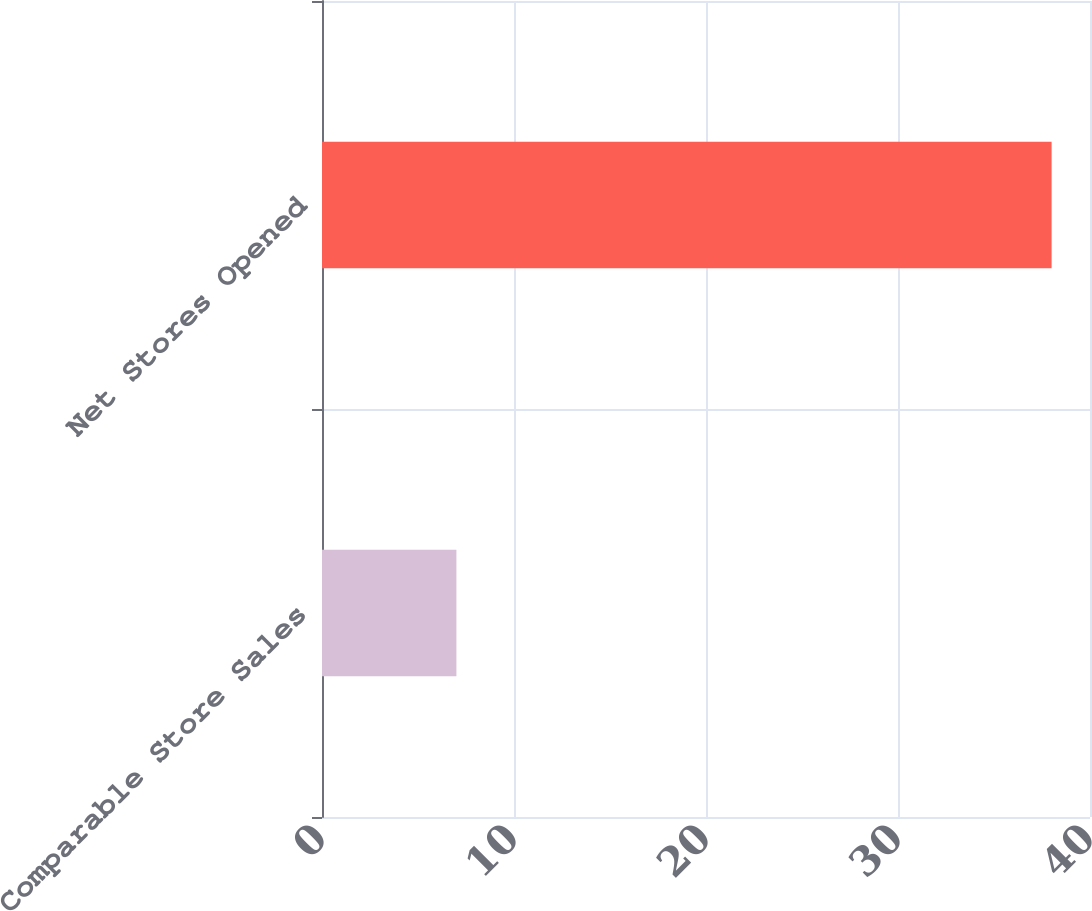Convert chart. <chart><loc_0><loc_0><loc_500><loc_500><bar_chart><fcel>Comparable Store Sales<fcel>Net Stores Opened<nl><fcel>7<fcel>38<nl></chart> 